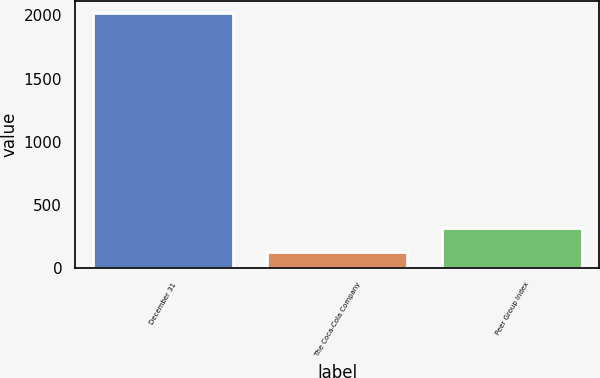Convert chart to OTSL. <chart><loc_0><loc_0><loc_500><loc_500><bar_chart><fcel>December 31<fcel>The Coca-Cola Company<fcel>Peer Group Index<nl><fcel>2017<fcel>126<fcel>315.1<nl></chart> 